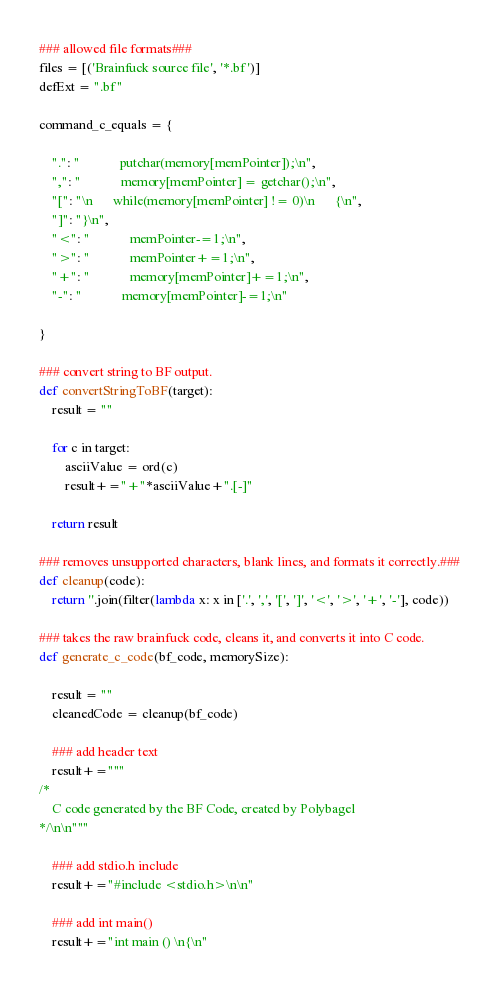Convert code to text. <code><loc_0><loc_0><loc_500><loc_500><_Python_>### allowed file formats###
files = [('Brainfuck source file', '*.bf')]
defExt = ".bf"

command_c_equals = {

    ".": "            putchar(memory[memPointer]);\n",
    ",": "            memory[memPointer] = getchar();\n",
    "[": "\n      while(memory[memPointer] != 0)\n      {\n",
    "]": "}\n",
    "<": "            memPointer-=1;\n",
    ">": "            memPointer+=1;\n",
    "+": "            memory[memPointer]+=1;\n",
    "-": "            memory[memPointer]-=1;\n"

}

### convert string to BF output.
def convertStringToBF(target):
    result = ""
    
    for c in target:
        asciiValue = ord(c)
        result+="+"*asciiValue+".[-]"

    return result

### removes unsupported characters, blank lines, and formats it correctly.###
def cleanup(code):
    return ''.join(filter(lambda x: x in ['.', ',', '[', ']', '<', '>', '+', '-'], code))

### takes the raw brainfuck code, cleans it, and converts it into C code.
def generate_c_code(bf_code, memorySize):

    result = ""
    cleanedCode = cleanup(bf_code)

    ### add header text
    result+="""
/*
    C code generated by the BF Code, created by Polybagel
*/\n\n"""

    ### add stdio.h include
    result+="#include <stdio.h>\n\n"

    ### add int main()
    result+="int main () \n{\n"
</code> 